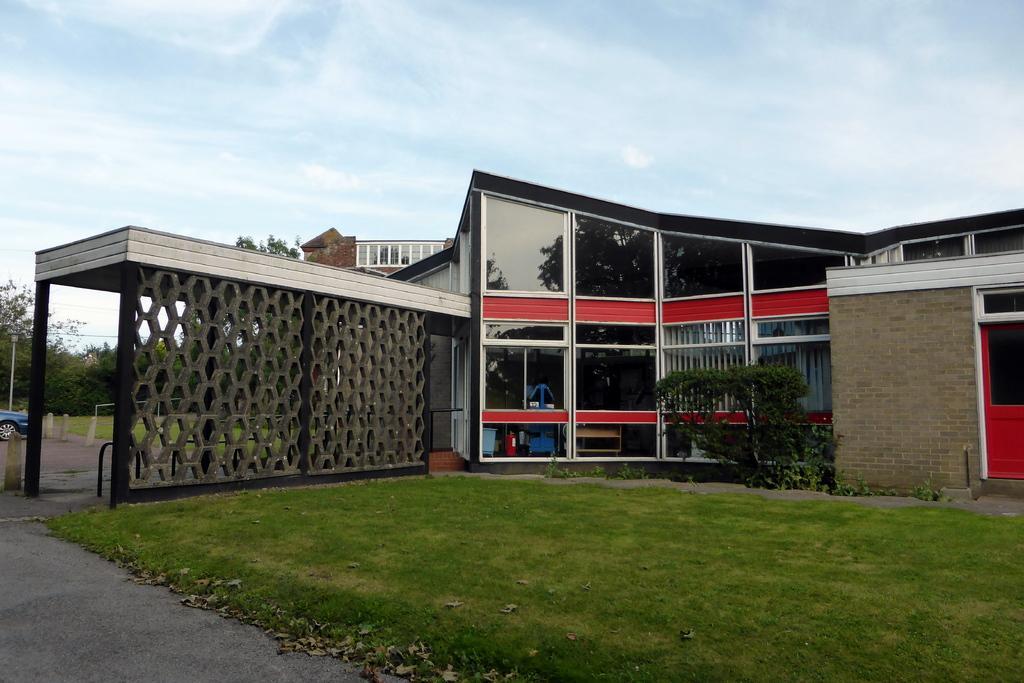Could you give a brief overview of what you see in this image? This image is taken outdoors. At the top of the image there is a sky with clouds. At the bottom of the image there is a road and a ground with grass on it. In the middle of the image there is a house with walls, windows, doors, railings and a roof. On the left side of the image there are a few trees and a car is parked on the ground. 